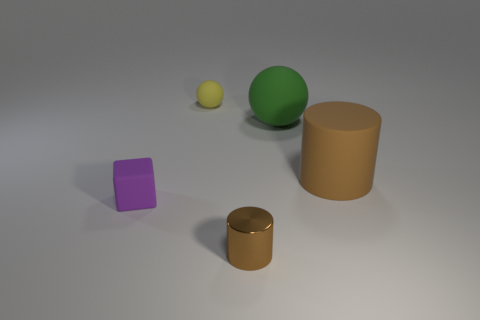Add 1 big gray metallic things. How many objects exist? 6 Subtract all cylinders. How many objects are left? 3 Add 5 small matte cubes. How many small matte cubes are left? 6 Add 2 large balls. How many large balls exist? 3 Subtract 0 green cubes. How many objects are left? 5 Subtract all big green blocks. Subtract all purple things. How many objects are left? 4 